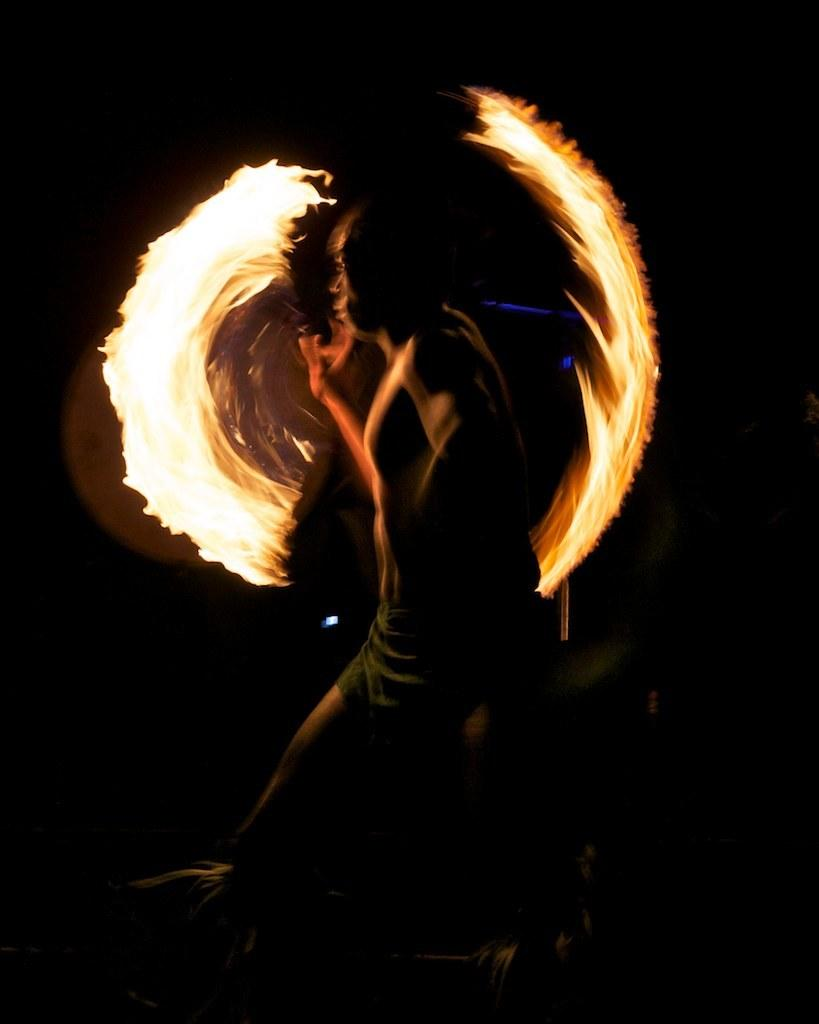What is the main subject in the foreground of the image? There is a person in the foreground of the image. What is the person doing in the image? The person appears to be walking. What can be observed about the background of the image? The background of the image is dark. What is the source of light in the background? There is fire visible in the background. What type of parcel is the person carrying in their mouth in the image? There is no parcel visible in the image, and the person is not carrying anything in their mouth. 